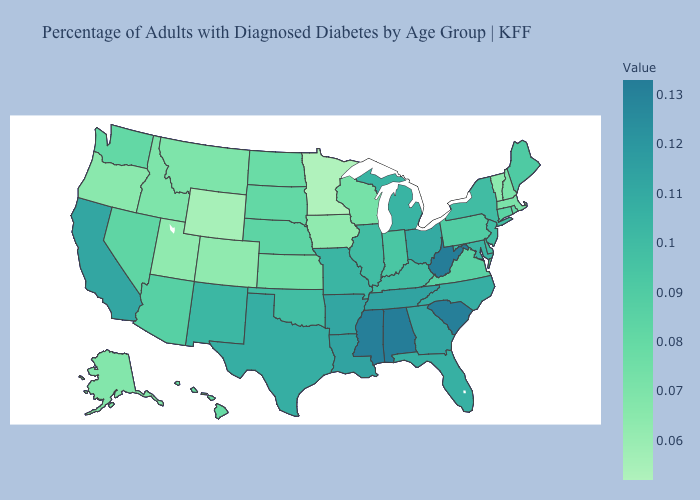Is the legend a continuous bar?
Give a very brief answer. Yes. Does Ohio have the highest value in the MidWest?
Give a very brief answer. Yes. Which states have the lowest value in the USA?
Give a very brief answer. Minnesota. Does the map have missing data?
Short answer required. No. Does California have the highest value in the West?
Give a very brief answer. Yes. Does Maryland have the highest value in the USA?
Concise answer only. No. Does Louisiana have a higher value than Mississippi?
Write a very short answer. No. Does West Virginia have the highest value in the South?
Short answer required. Yes. 